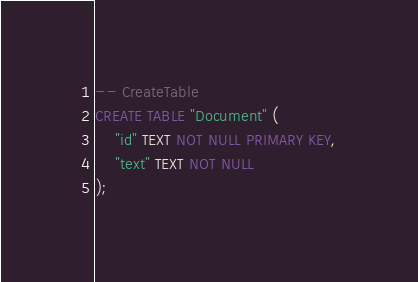<code> <loc_0><loc_0><loc_500><loc_500><_SQL_>-- CreateTable
CREATE TABLE "Document" (
    "id" TEXT NOT NULL PRIMARY KEY,
    "text" TEXT NOT NULL
);
</code> 